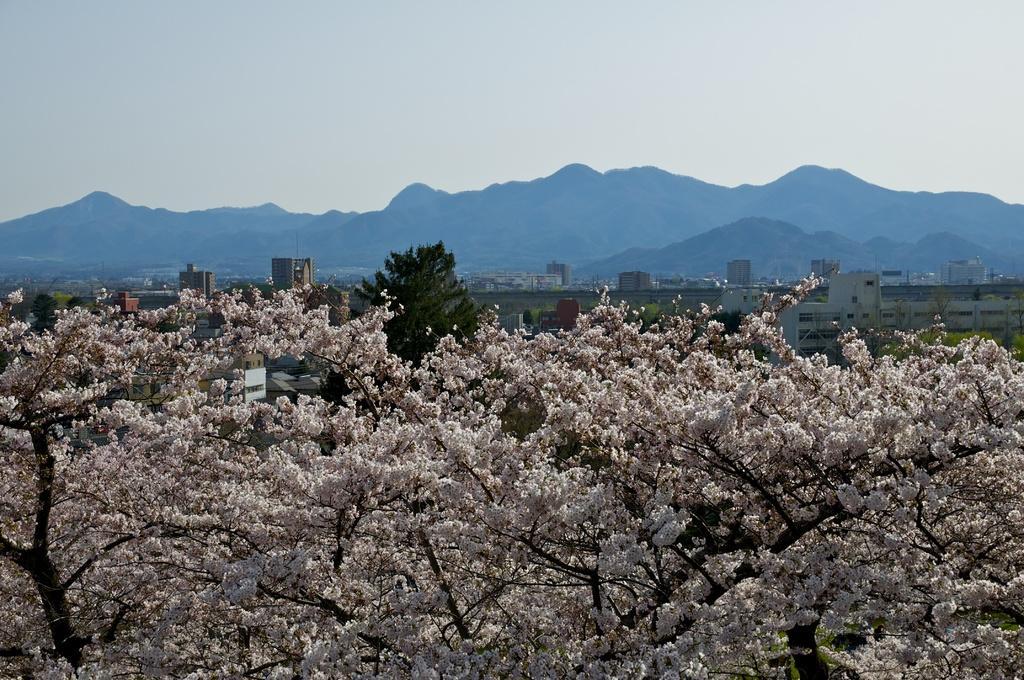Could you give a brief overview of what you see in this image? In the foreground of the picture there are trees. In the center of the picture there are buildings and trees. In the background there are hills. Sky is cloudy. 